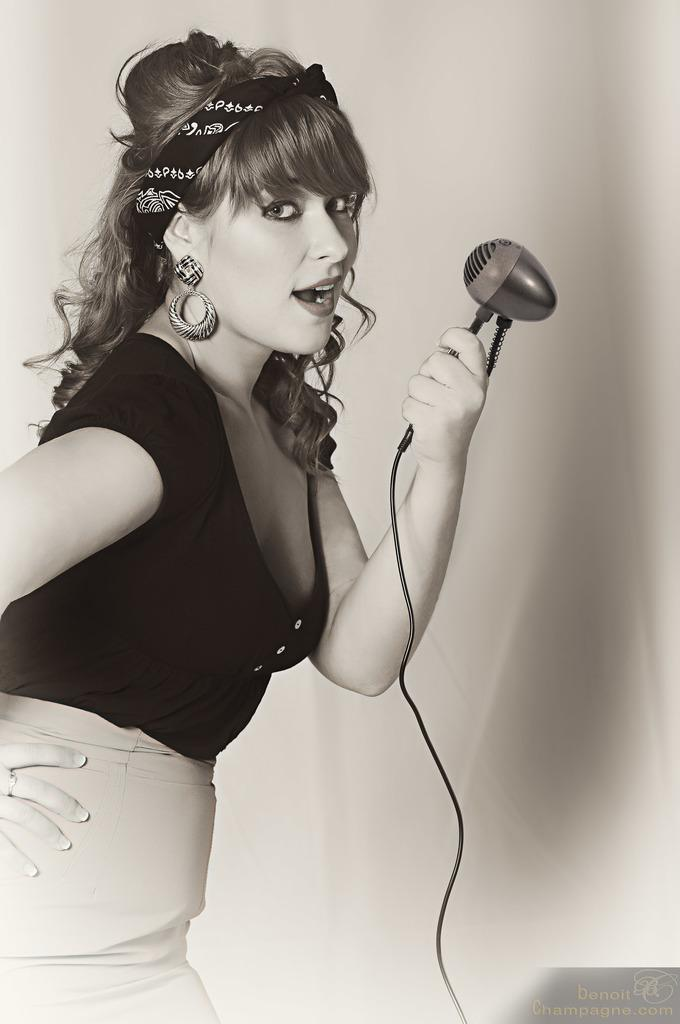What is the main subject of the image? The main subject of the image is a woman. What is the woman wearing on her upper body? The woman is wearing a black top. What is the woman wearing on her lower body? The woman is wearing biscuit-colored bottoms. What object is the woman holding in the image? The woman is holding a microphone. How would you describe the woman's hairstyle? The woman has short hair. What is the woman's focus in the image? The woman is staring at something. How many mittens can be seen on the woman's hands in the image? There are no mittens present on the woman's hands in the image. What type of rabbits can be seen in the image? There are no rabbits present in the image. 